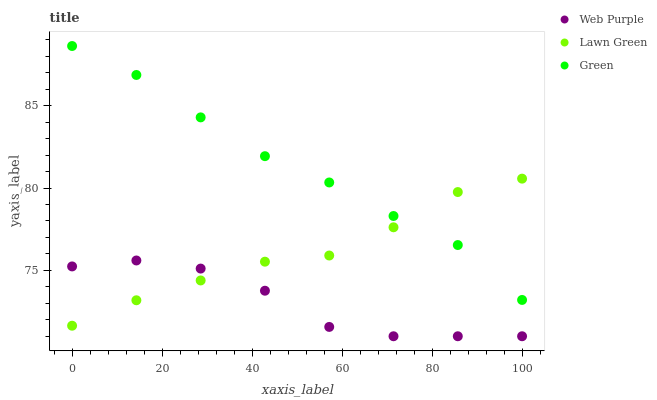Does Web Purple have the minimum area under the curve?
Answer yes or no. Yes. Does Green have the maximum area under the curve?
Answer yes or no. Yes. Does Green have the minimum area under the curve?
Answer yes or no. No. Does Web Purple have the maximum area under the curve?
Answer yes or no. No. Is Green the smoothest?
Answer yes or no. Yes. Is Web Purple the roughest?
Answer yes or no. Yes. Is Web Purple the smoothest?
Answer yes or no. No. Is Green the roughest?
Answer yes or no. No. Does Web Purple have the lowest value?
Answer yes or no. Yes. Does Green have the lowest value?
Answer yes or no. No. Does Green have the highest value?
Answer yes or no. Yes. Does Web Purple have the highest value?
Answer yes or no. No. Is Web Purple less than Green?
Answer yes or no. Yes. Is Green greater than Web Purple?
Answer yes or no. Yes. Does Lawn Green intersect Web Purple?
Answer yes or no. Yes. Is Lawn Green less than Web Purple?
Answer yes or no. No. Is Lawn Green greater than Web Purple?
Answer yes or no. No. Does Web Purple intersect Green?
Answer yes or no. No. 